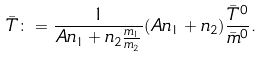Convert formula to latex. <formula><loc_0><loc_0><loc_500><loc_500>\bar { T } \colon = \frac { 1 } { A n _ { 1 } + n _ { 2 } \frac { m _ { 1 } } { m _ { 2 } } } ( A n _ { 1 } + n _ { 2 } ) \frac { \bar { T } ^ { 0 } } { \bar { m } ^ { 0 } } .</formula> 